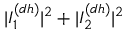Convert formula to latex. <formula><loc_0><loc_0><loc_500><loc_500>| I _ { 1 } ^ { ( d h ) } | ^ { 2 } + | I _ { 2 } ^ { ( d h ) } | ^ { 2 }</formula> 